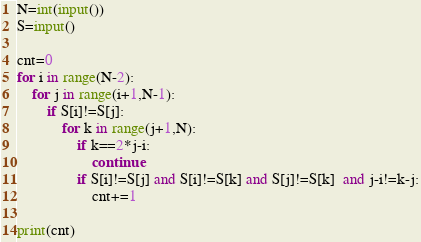<code> <loc_0><loc_0><loc_500><loc_500><_Python_>N=int(input())
S=input()

cnt=0
for i in range(N-2):
    for j in range(i+1,N-1):
        if S[i]!=S[j]:
            for k in range(j+1,N):
                if k==2*j-i:
                    continue             
                if S[i]!=S[j] and S[i]!=S[k] and S[j]!=S[k]  and j-i!=k-j:
                    cnt+=1

print(cnt)
</code> 